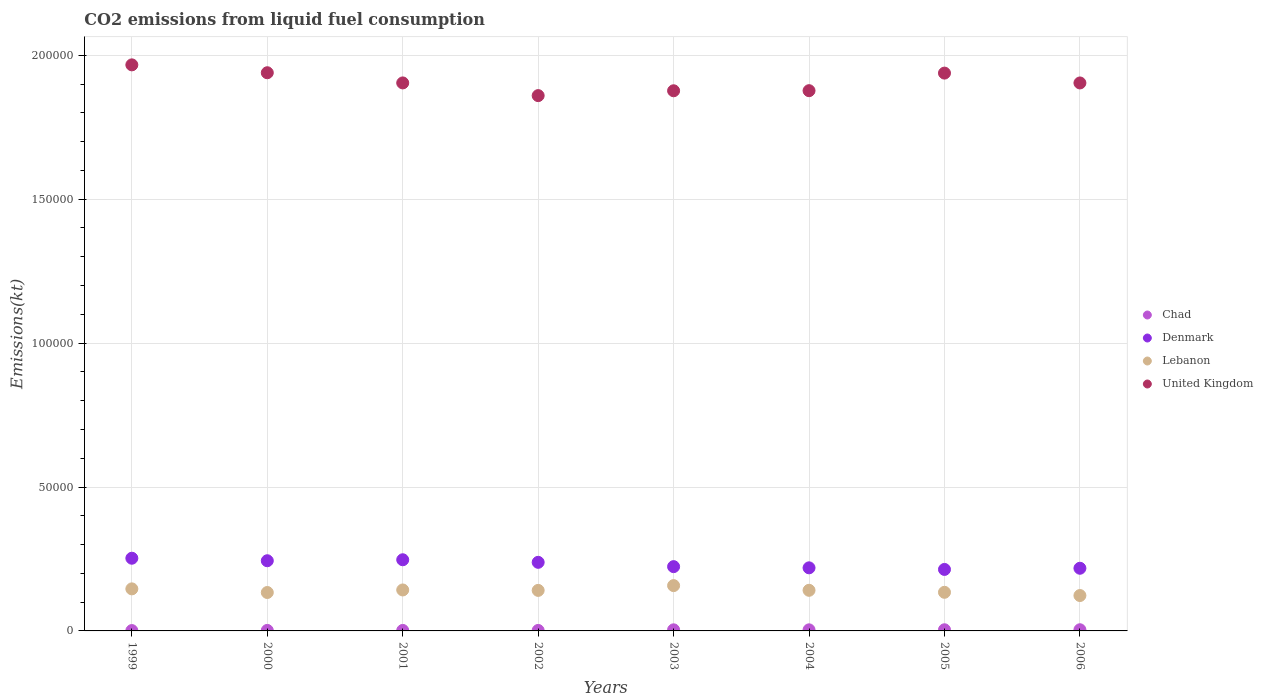How many different coloured dotlines are there?
Provide a succinct answer. 4. What is the amount of CO2 emitted in Chad in 2005?
Offer a terse response. 399.7. Across all years, what is the maximum amount of CO2 emitted in Lebanon?
Offer a very short reply. 1.57e+04. Across all years, what is the minimum amount of CO2 emitted in United Kingdom?
Your answer should be compact. 1.86e+05. In which year was the amount of CO2 emitted in United Kingdom maximum?
Make the answer very short. 1999. In which year was the amount of CO2 emitted in Lebanon minimum?
Ensure brevity in your answer.  2006. What is the total amount of CO2 emitted in Denmark in the graph?
Provide a succinct answer. 1.86e+05. What is the difference between the amount of CO2 emitted in United Kingdom in 2003 and that in 2006?
Make the answer very short. -2717.25. What is the difference between the amount of CO2 emitted in Chad in 2006 and the amount of CO2 emitted in United Kingdom in 2000?
Your answer should be compact. -1.94e+05. What is the average amount of CO2 emitted in Lebanon per year?
Provide a succinct answer. 1.40e+04. In the year 2004, what is the difference between the amount of CO2 emitted in Lebanon and amount of CO2 emitted in Chad?
Provide a short and direct response. 1.37e+04. What is the ratio of the amount of CO2 emitted in Chad in 2000 to that in 2002?
Ensure brevity in your answer.  1.04. Is the difference between the amount of CO2 emitted in Lebanon in 2005 and 2006 greater than the difference between the amount of CO2 emitted in Chad in 2005 and 2006?
Provide a succinct answer. Yes. What is the difference between the highest and the second highest amount of CO2 emitted in Denmark?
Give a very brief answer. 531.72. What is the difference between the highest and the lowest amount of CO2 emitted in Denmark?
Provide a succinct answer. 3890.69. In how many years, is the amount of CO2 emitted in Denmark greater than the average amount of CO2 emitted in Denmark taken over all years?
Provide a succinct answer. 4. Is it the case that in every year, the sum of the amount of CO2 emitted in Denmark and amount of CO2 emitted in Chad  is greater than the amount of CO2 emitted in United Kingdom?
Offer a terse response. No. Does the amount of CO2 emitted in Lebanon monotonically increase over the years?
Your answer should be very brief. No. How many years are there in the graph?
Ensure brevity in your answer.  8. Are the values on the major ticks of Y-axis written in scientific E-notation?
Your response must be concise. No. Does the graph contain grids?
Your answer should be very brief. Yes. How many legend labels are there?
Make the answer very short. 4. How are the legend labels stacked?
Ensure brevity in your answer.  Vertical. What is the title of the graph?
Provide a short and direct response. CO2 emissions from liquid fuel consumption. Does "Denmark" appear as one of the legend labels in the graph?
Your answer should be very brief. Yes. What is the label or title of the Y-axis?
Provide a succinct answer. Emissions(kt). What is the Emissions(kt) of Chad in 1999?
Provide a short and direct response. 121.01. What is the Emissions(kt) of Denmark in 1999?
Your response must be concise. 2.53e+04. What is the Emissions(kt) in Lebanon in 1999?
Offer a very short reply. 1.46e+04. What is the Emissions(kt) in United Kingdom in 1999?
Provide a short and direct response. 1.97e+05. What is the Emissions(kt) of Chad in 2000?
Keep it short and to the point. 176.02. What is the Emissions(kt) of Denmark in 2000?
Your response must be concise. 2.44e+04. What is the Emissions(kt) in Lebanon in 2000?
Offer a terse response. 1.33e+04. What is the Emissions(kt) in United Kingdom in 2000?
Give a very brief answer. 1.94e+05. What is the Emissions(kt) in Chad in 2001?
Offer a terse response. 172.35. What is the Emissions(kt) of Denmark in 2001?
Offer a very short reply. 2.47e+04. What is the Emissions(kt) of Lebanon in 2001?
Keep it short and to the point. 1.42e+04. What is the Emissions(kt) in United Kingdom in 2001?
Ensure brevity in your answer.  1.90e+05. What is the Emissions(kt) in Chad in 2002?
Offer a terse response. 168.68. What is the Emissions(kt) of Denmark in 2002?
Your response must be concise. 2.38e+04. What is the Emissions(kt) of Lebanon in 2002?
Offer a very short reply. 1.41e+04. What is the Emissions(kt) in United Kingdom in 2002?
Offer a terse response. 1.86e+05. What is the Emissions(kt) in Chad in 2003?
Provide a succinct answer. 381.37. What is the Emissions(kt) in Denmark in 2003?
Offer a terse response. 2.23e+04. What is the Emissions(kt) in Lebanon in 2003?
Offer a very short reply. 1.57e+04. What is the Emissions(kt) in United Kingdom in 2003?
Provide a succinct answer. 1.88e+05. What is the Emissions(kt) in Chad in 2004?
Your answer should be very brief. 377.7. What is the Emissions(kt) of Denmark in 2004?
Your response must be concise. 2.19e+04. What is the Emissions(kt) in Lebanon in 2004?
Make the answer very short. 1.41e+04. What is the Emissions(kt) of United Kingdom in 2004?
Your response must be concise. 1.88e+05. What is the Emissions(kt) of Chad in 2005?
Your response must be concise. 399.7. What is the Emissions(kt) in Denmark in 2005?
Make the answer very short. 2.14e+04. What is the Emissions(kt) in Lebanon in 2005?
Provide a short and direct response. 1.34e+04. What is the Emissions(kt) of United Kingdom in 2005?
Provide a short and direct response. 1.94e+05. What is the Emissions(kt) in Chad in 2006?
Make the answer very short. 407.04. What is the Emissions(kt) in Denmark in 2006?
Give a very brief answer. 2.18e+04. What is the Emissions(kt) of Lebanon in 2006?
Give a very brief answer. 1.23e+04. What is the Emissions(kt) in United Kingdom in 2006?
Provide a succinct answer. 1.90e+05. Across all years, what is the maximum Emissions(kt) of Chad?
Offer a terse response. 407.04. Across all years, what is the maximum Emissions(kt) in Denmark?
Keep it short and to the point. 2.53e+04. Across all years, what is the maximum Emissions(kt) in Lebanon?
Keep it short and to the point. 1.57e+04. Across all years, what is the maximum Emissions(kt) of United Kingdom?
Give a very brief answer. 1.97e+05. Across all years, what is the minimum Emissions(kt) in Chad?
Your response must be concise. 121.01. Across all years, what is the minimum Emissions(kt) of Denmark?
Offer a very short reply. 2.14e+04. Across all years, what is the minimum Emissions(kt) in Lebanon?
Your response must be concise. 1.23e+04. Across all years, what is the minimum Emissions(kt) of United Kingdom?
Provide a short and direct response. 1.86e+05. What is the total Emissions(kt) in Chad in the graph?
Provide a succinct answer. 2203.87. What is the total Emissions(kt) of Denmark in the graph?
Provide a short and direct response. 1.86e+05. What is the total Emissions(kt) in Lebanon in the graph?
Your response must be concise. 1.12e+05. What is the total Emissions(kt) in United Kingdom in the graph?
Offer a very short reply. 1.53e+06. What is the difference between the Emissions(kt) of Chad in 1999 and that in 2000?
Ensure brevity in your answer.  -55.01. What is the difference between the Emissions(kt) of Denmark in 1999 and that in 2000?
Ensure brevity in your answer.  872.75. What is the difference between the Emissions(kt) in Lebanon in 1999 and that in 2000?
Provide a succinct answer. 1261.45. What is the difference between the Emissions(kt) in United Kingdom in 1999 and that in 2000?
Your answer should be very brief. 2739.25. What is the difference between the Emissions(kt) in Chad in 1999 and that in 2001?
Give a very brief answer. -51.34. What is the difference between the Emissions(kt) of Denmark in 1999 and that in 2001?
Ensure brevity in your answer.  531.72. What is the difference between the Emissions(kt) in Lebanon in 1999 and that in 2001?
Ensure brevity in your answer.  377.7. What is the difference between the Emissions(kt) of United Kingdom in 1999 and that in 2001?
Provide a succinct answer. 6274.24. What is the difference between the Emissions(kt) of Chad in 1999 and that in 2002?
Your answer should be very brief. -47.67. What is the difference between the Emissions(kt) in Denmark in 1999 and that in 2002?
Provide a succinct answer. 1422.8. What is the difference between the Emissions(kt) in Lebanon in 1999 and that in 2002?
Your answer should be compact. 528.05. What is the difference between the Emissions(kt) in United Kingdom in 1999 and that in 2002?
Offer a terse response. 1.07e+04. What is the difference between the Emissions(kt) in Chad in 1999 and that in 2003?
Your answer should be compact. -260.36. What is the difference between the Emissions(kt) of Denmark in 1999 and that in 2003?
Keep it short and to the point. 2922.6. What is the difference between the Emissions(kt) of Lebanon in 1999 and that in 2003?
Your answer should be compact. -1133.1. What is the difference between the Emissions(kt) in United Kingdom in 1999 and that in 2003?
Make the answer very short. 9002.49. What is the difference between the Emissions(kt) of Chad in 1999 and that in 2004?
Offer a terse response. -256.69. What is the difference between the Emissions(kt) in Denmark in 1999 and that in 2004?
Offer a very short reply. 3336.97. What is the difference between the Emissions(kt) in Lebanon in 1999 and that in 2004?
Provide a succinct answer. 498.71. What is the difference between the Emissions(kt) of United Kingdom in 1999 and that in 2004?
Give a very brief answer. 8969.48. What is the difference between the Emissions(kt) in Chad in 1999 and that in 2005?
Provide a short and direct response. -278.69. What is the difference between the Emissions(kt) in Denmark in 1999 and that in 2005?
Keep it short and to the point. 3890.69. What is the difference between the Emissions(kt) in Lebanon in 1999 and that in 2005?
Your response must be concise. 1191.78. What is the difference between the Emissions(kt) in United Kingdom in 1999 and that in 2005?
Offer a terse response. 2863.93. What is the difference between the Emissions(kt) of Chad in 1999 and that in 2006?
Your answer should be compact. -286.03. What is the difference between the Emissions(kt) in Denmark in 1999 and that in 2006?
Your response must be concise. 3483.65. What is the difference between the Emissions(kt) in Lebanon in 1999 and that in 2006?
Your answer should be very brief. 2313.88. What is the difference between the Emissions(kt) of United Kingdom in 1999 and that in 2006?
Offer a terse response. 6285.24. What is the difference between the Emissions(kt) of Chad in 2000 and that in 2001?
Give a very brief answer. 3.67. What is the difference between the Emissions(kt) of Denmark in 2000 and that in 2001?
Offer a very short reply. -341.03. What is the difference between the Emissions(kt) of Lebanon in 2000 and that in 2001?
Make the answer very short. -883.75. What is the difference between the Emissions(kt) of United Kingdom in 2000 and that in 2001?
Offer a terse response. 3534.99. What is the difference between the Emissions(kt) in Chad in 2000 and that in 2002?
Make the answer very short. 7.33. What is the difference between the Emissions(kt) of Denmark in 2000 and that in 2002?
Your response must be concise. 550.05. What is the difference between the Emissions(kt) of Lebanon in 2000 and that in 2002?
Offer a terse response. -733.4. What is the difference between the Emissions(kt) in United Kingdom in 2000 and that in 2002?
Offer a very short reply. 7946.39. What is the difference between the Emissions(kt) of Chad in 2000 and that in 2003?
Provide a succinct answer. -205.35. What is the difference between the Emissions(kt) in Denmark in 2000 and that in 2003?
Offer a very short reply. 2049.85. What is the difference between the Emissions(kt) in Lebanon in 2000 and that in 2003?
Ensure brevity in your answer.  -2394.55. What is the difference between the Emissions(kt) of United Kingdom in 2000 and that in 2003?
Provide a succinct answer. 6263.24. What is the difference between the Emissions(kt) in Chad in 2000 and that in 2004?
Provide a short and direct response. -201.69. What is the difference between the Emissions(kt) in Denmark in 2000 and that in 2004?
Offer a terse response. 2464.22. What is the difference between the Emissions(kt) in Lebanon in 2000 and that in 2004?
Your answer should be very brief. -762.74. What is the difference between the Emissions(kt) of United Kingdom in 2000 and that in 2004?
Provide a succinct answer. 6230.23. What is the difference between the Emissions(kt) in Chad in 2000 and that in 2005?
Your response must be concise. -223.69. What is the difference between the Emissions(kt) in Denmark in 2000 and that in 2005?
Your answer should be very brief. 3017.94. What is the difference between the Emissions(kt) of Lebanon in 2000 and that in 2005?
Give a very brief answer. -69.67. What is the difference between the Emissions(kt) in United Kingdom in 2000 and that in 2005?
Give a very brief answer. 124.68. What is the difference between the Emissions(kt) of Chad in 2000 and that in 2006?
Keep it short and to the point. -231.02. What is the difference between the Emissions(kt) of Denmark in 2000 and that in 2006?
Offer a very short reply. 2610.9. What is the difference between the Emissions(kt) of Lebanon in 2000 and that in 2006?
Give a very brief answer. 1052.43. What is the difference between the Emissions(kt) in United Kingdom in 2000 and that in 2006?
Your answer should be very brief. 3545.99. What is the difference between the Emissions(kt) of Chad in 2001 and that in 2002?
Offer a terse response. 3.67. What is the difference between the Emissions(kt) of Denmark in 2001 and that in 2002?
Keep it short and to the point. 891.08. What is the difference between the Emissions(kt) of Lebanon in 2001 and that in 2002?
Offer a very short reply. 150.35. What is the difference between the Emissions(kt) in United Kingdom in 2001 and that in 2002?
Provide a short and direct response. 4411.4. What is the difference between the Emissions(kt) of Chad in 2001 and that in 2003?
Your answer should be compact. -209.02. What is the difference between the Emissions(kt) of Denmark in 2001 and that in 2003?
Keep it short and to the point. 2390.88. What is the difference between the Emissions(kt) in Lebanon in 2001 and that in 2003?
Offer a very short reply. -1510.8. What is the difference between the Emissions(kt) of United Kingdom in 2001 and that in 2003?
Ensure brevity in your answer.  2728.25. What is the difference between the Emissions(kt) in Chad in 2001 and that in 2004?
Your answer should be compact. -205.35. What is the difference between the Emissions(kt) in Denmark in 2001 and that in 2004?
Keep it short and to the point. 2805.26. What is the difference between the Emissions(kt) in Lebanon in 2001 and that in 2004?
Keep it short and to the point. 121.01. What is the difference between the Emissions(kt) of United Kingdom in 2001 and that in 2004?
Your answer should be very brief. 2695.24. What is the difference between the Emissions(kt) of Chad in 2001 and that in 2005?
Provide a succinct answer. -227.35. What is the difference between the Emissions(kt) in Denmark in 2001 and that in 2005?
Provide a short and direct response. 3358.97. What is the difference between the Emissions(kt) in Lebanon in 2001 and that in 2005?
Give a very brief answer. 814.07. What is the difference between the Emissions(kt) in United Kingdom in 2001 and that in 2005?
Offer a very short reply. -3410.31. What is the difference between the Emissions(kt) of Chad in 2001 and that in 2006?
Your response must be concise. -234.69. What is the difference between the Emissions(kt) of Denmark in 2001 and that in 2006?
Give a very brief answer. 2951.93. What is the difference between the Emissions(kt) in Lebanon in 2001 and that in 2006?
Your answer should be compact. 1936.18. What is the difference between the Emissions(kt) in United Kingdom in 2001 and that in 2006?
Your response must be concise. 11. What is the difference between the Emissions(kt) of Chad in 2002 and that in 2003?
Provide a succinct answer. -212.69. What is the difference between the Emissions(kt) in Denmark in 2002 and that in 2003?
Make the answer very short. 1499.8. What is the difference between the Emissions(kt) of Lebanon in 2002 and that in 2003?
Provide a short and direct response. -1661.15. What is the difference between the Emissions(kt) of United Kingdom in 2002 and that in 2003?
Your answer should be compact. -1683.15. What is the difference between the Emissions(kt) of Chad in 2002 and that in 2004?
Keep it short and to the point. -209.02. What is the difference between the Emissions(kt) of Denmark in 2002 and that in 2004?
Offer a terse response. 1914.17. What is the difference between the Emissions(kt) of Lebanon in 2002 and that in 2004?
Give a very brief answer. -29.34. What is the difference between the Emissions(kt) in United Kingdom in 2002 and that in 2004?
Your response must be concise. -1716.16. What is the difference between the Emissions(kt) of Chad in 2002 and that in 2005?
Your answer should be compact. -231.02. What is the difference between the Emissions(kt) in Denmark in 2002 and that in 2005?
Give a very brief answer. 2467.89. What is the difference between the Emissions(kt) of Lebanon in 2002 and that in 2005?
Provide a succinct answer. 663.73. What is the difference between the Emissions(kt) in United Kingdom in 2002 and that in 2005?
Offer a terse response. -7821.71. What is the difference between the Emissions(kt) of Chad in 2002 and that in 2006?
Ensure brevity in your answer.  -238.35. What is the difference between the Emissions(kt) of Denmark in 2002 and that in 2006?
Provide a succinct answer. 2060.85. What is the difference between the Emissions(kt) of Lebanon in 2002 and that in 2006?
Offer a very short reply. 1785.83. What is the difference between the Emissions(kt) in United Kingdom in 2002 and that in 2006?
Offer a terse response. -4400.4. What is the difference between the Emissions(kt) in Chad in 2003 and that in 2004?
Give a very brief answer. 3.67. What is the difference between the Emissions(kt) in Denmark in 2003 and that in 2004?
Offer a very short reply. 414.37. What is the difference between the Emissions(kt) of Lebanon in 2003 and that in 2004?
Offer a very short reply. 1631.82. What is the difference between the Emissions(kt) in United Kingdom in 2003 and that in 2004?
Offer a terse response. -33. What is the difference between the Emissions(kt) in Chad in 2003 and that in 2005?
Your response must be concise. -18.34. What is the difference between the Emissions(kt) of Denmark in 2003 and that in 2005?
Provide a succinct answer. 968.09. What is the difference between the Emissions(kt) of Lebanon in 2003 and that in 2005?
Give a very brief answer. 2324.88. What is the difference between the Emissions(kt) in United Kingdom in 2003 and that in 2005?
Your answer should be very brief. -6138.56. What is the difference between the Emissions(kt) in Chad in 2003 and that in 2006?
Provide a short and direct response. -25.67. What is the difference between the Emissions(kt) in Denmark in 2003 and that in 2006?
Provide a short and direct response. 561.05. What is the difference between the Emissions(kt) of Lebanon in 2003 and that in 2006?
Give a very brief answer. 3446.98. What is the difference between the Emissions(kt) of United Kingdom in 2003 and that in 2006?
Provide a short and direct response. -2717.25. What is the difference between the Emissions(kt) in Chad in 2004 and that in 2005?
Make the answer very short. -22. What is the difference between the Emissions(kt) of Denmark in 2004 and that in 2005?
Provide a short and direct response. 553.72. What is the difference between the Emissions(kt) in Lebanon in 2004 and that in 2005?
Keep it short and to the point. 693.06. What is the difference between the Emissions(kt) in United Kingdom in 2004 and that in 2005?
Make the answer very short. -6105.56. What is the difference between the Emissions(kt) of Chad in 2004 and that in 2006?
Your answer should be very brief. -29.34. What is the difference between the Emissions(kt) of Denmark in 2004 and that in 2006?
Your response must be concise. 146.68. What is the difference between the Emissions(kt) in Lebanon in 2004 and that in 2006?
Offer a terse response. 1815.16. What is the difference between the Emissions(kt) of United Kingdom in 2004 and that in 2006?
Offer a very short reply. -2684.24. What is the difference between the Emissions(kt) of Chad in 2005 and that in 2006?
Keep it short and to the point. -7.33. What is the difference between the Emissions(kt) of Denmark in 2005 and that in 2006?
Give a very brief answer. -407.04. What is the difference between the Emissions(kt) in Lebanon in 2005 and that in 2006?
Your answer should be compact. 1122.1. What is the difference between the Emissions(kt) of United Kingdom in 2005 and that in 2006?
Your answer should be compact. 3421.31. What is the difference between the Emissions(kt) of Chad in 1999 and the Emissions(kt) of Denmark in 2000?
Ensure brevity in your answer.  -2.43e+04. What is the difference between the Emissions(kt) in Chad in 1999 and the Emissions(kt) in Lebanon in 2000?
Ensure brevity in your answer.  -1.32e+04. What is the difference between the Emissions(kt) in Chad in 1999 and the Emissions(kt) in United Kingdom in 2000?
Your answer should be compact. -1.94e+05. What is the difference between the Emissions(kt) of Denmark in 1999 and the Emissions(kt) of Lebanon in 2000?
Offer a terse response. 1.19e+04. What is the difference between the Emissions(kt) in Denmark in 1999 and the Emissions(kt) in United Kingdom in 2000?
Offer a terse response. -1.69e+05. What is the difference between the Emissions(kt) of Lebanon in 1999 and the Emissions(kt) of United Kingdom in 2000?
Ensure brevity in your answer.  -1.79e+05. What is the difference between the Emissions(kt) in Chad in 1999 and the Emissions(kt) in Denmark in 2001?
Offer a very short reply. -2.46e+04. What is the difference between the Emissions(kt) in Chad in 1999 and the Emissions(kt) in Lebanon in 2001?
Provide a short and direct response. -1.41e+04. What is the difference between the Emissions(kt) in Chad in 1999 and the Emissions(kt) in United Kingdom in 2001?
Your response must be concise. -1.90e+05. What is the difference between the Emissions(kt) of Denmark in 1999 and the Emissions(kt) of Lebanon in 2001?
Your response must be concise. 1.10e+04. What is the difference between the Emissions(kt) in Denmark in 1999 and the Emissions(kt) in United Kingdom in 2001?
Offer a terse response. -1.65e+05. What is the difference between the Emissions(kt) in Lebanon in 1999 and the Emissions(kt) in United Kingdom in 2001?
Offer a terse response. -1.76e+05. What is the difference between the Emissions(kt) of Chad in 1999 and the Emissions(kt) of Denmark in 2002?
Your answer should be very brief. -2.37e+04. What is the difference between the Emissions(kt) of Chad in 1999 and the Emissions(kt) of Lebanon in 2002?
Your response must be concise. -1.40e+04. What is the difference between the Emissions(kt) in Chad in 1999 and the Emissions(kt) in United Kingdom in 2002?
Ensure brevity in your answer.  -1.86e+05. What is the difference between the Emissions(kt) in Denmark in 1999 and the Emissions(kt) in Lebanon in 2002?
Ensure brevity in your answer.  1.12e+04. What is the difference between the Emissions(kt) in Denmark in 1999 and the Emissions(kt) in United Kingdom in 2002?
Keep it short and to the point. -1.61e+05. What is the difference between the Emissions(kt) of Lebanon in 1999 and the Emissions(kt) of United Kingdom in 2002?
Offer a terse response. -1.71e+05. What is the difference between the Emissions(kt) in Chad in 1999 and the Emissions(kt) in Denmark in 2003?
Make the answer very short. -2.22e+04. What is the difference between the Emissions(kt) of Chad in 1999 and the Emissions(kt) of Lebanon in 2003?
Provide a succinct answer. -1.56e+04. What is the difference between the Emissions(kt) of Chad in 1999 and the Emissions(kt) of United Kingdom in 2003?
Your answer should be compact. -1.88e+05. What is the difference between the Emissions(kt) of Denmark in 1999 and the Emissions(kt) of Lebanon in 2003?
Ensure brevity in your answer.  9512.2. What is the difference between the Emissions(kt) in Denmark in 1999 and the Emissions(kt) in United Kingdom in 2003?
Keep it short and to the point. -1.62e+05. What is the difference between the Emissions(kt) of Lebanon in 1999 and the Emissions(kt) of United Kingdom in 2003?
Your answer should be compact. -1.73e+05. What is the difference between the Emissions(kt) in Chad in 1999 and the Emissions(kt) in Denmark in 2004?
Make the answer very short. -2.18e+04. What is the difference between the Emissions(kt) of Chad in 1999 and the Emissions(kt) of Lebanon in 2004?
Provide a succinct answer. -1.40e+04. What is the difference between the Emissions(kt) in Chad in 1999 and the Emissions(kt) in United Kingdom in 2004?
Offer a terse response. -1.88e+05. What is the difference between the Emissions(kt) in Denmark in 1999 and the Emissions(kt) in Lebanon in 2004?
Your answer should be very brief. 1.11e+04. What is the difference between the Emissions(kt) of Denmark in 1999 and the Emissions(kt) of United Kingdom in 2004?
Your answer should be very brief. -1.62e+05. What is the difference between the Emissions(kt) of Lebanon in 1999 and the Emissions(kt) of United Kingdom in 2004?
Provide a short and direct response. -1.73e+05. What is the difference between the Emissions(kt) in Chad in 1999 and the Emissions(kt) in Denmark in 2005?
Ensure brevity in your answer.  -2.12e+04. What is the difference between the Emissions(kt) of Chad in 1999 and the Emissions(kt) of Lebanon in 2005?
Your answer should be compact. -1.33e+04. What is the difference between the Emissions(kt) of Chad in 1999 and the Emissions(kt) of United Kingdom in 2005?
Provide a succinct answer. -1.94e+05. What is the difference between the Emissions(kt) in Denmark in 1999 and the Emissions(kt) in Lebanon in 2005?
Your answer should be very brief. 1.18e+04. What is the difference between the Emissions(kt) in Denmark in 1999 and the Emissions(kt) in United Kingdom in 2005?
Your answer should be compact. -1.69e+05. What is the difference between the Emissions(kt) in Lebanon in 1999 and the Emissions(kt) in United Kingdom in 2005?
Ensure brevity in your answer.  -1.79e+05. What is the difference between the Emissions(kt) of Chad in 1999 and the Emissions(kt) of Denmark in 2006?
Make the answer very short. -2.16e+04. What is the difference between the Emissions(kt) of Chad in 1999 and the Emissions(kt) of Lebanon in 2006?
Ensure brevity in your answer.  -1.22e+04. What is the difference between the Emissions(kt) of Chad in 1999 and the Emissions(kt) of United Kingdom in 2006?
Ensure brevity in your answer.  -1.90e+05. What is the difference between the Emissions(kt) in Denmark in 1999 and the Emissions(kt) in Lebanon in 2006?
Your response must be concise. 1.30e+04. What is the difference between the Emissions(kt) in Denmark in 1999 and the Emissions(kt) in United Kingdom in 2006?
Give a very brief answer. -1.65e+05. What is the difference between the Emissions(kt) of Lebanon in 1999 and the Emissions(kt) of United Kingdom in 2006?
Ensure brevity in your answer.  -1.76e+05. What is the difference between the Emissions(kt) of Chad in 2000 and the Emissions(kt) of Denmark in 2001?
Offer a very short reply. -2.45e+04. What is the difference between the Emissions(kt) of Chad in 2000 and the Emissions(kt) of Lebanon in 2001?
Offer a terse response. -1.41e+04. What is the difference between the Emissions(kt) of Chad in 2000 and the Emissions(kt) of United Kingdom in 2001?
Offer a terse response. -1.90e+05. What is the difference between the Emissions(kt) in Denmark in 2000 and the Emissions(kt) in Lebanon in 2001?
Your response must be concise. 1.02e+04. What is the difference between the Emissions(kt) of Denmark in 2000 and the Emissions(kt) of United Kingdom in 2001?
Offer a terse response. -1.66e+05. What is the difference between the Emissions(kt) in Lebanon in 2000 and the Emissions(kt) in United Kingdom in 2001?
Offer a very short reply. -1.77e+05. What is the difference between the Emissions(kt) of Chad in 2000 and the Emissions(kt) of Denmark in 2002?
Your answer should be very brief. -2.37e+04. What is the difference between the Emissions(kt) in Chad in 2000 and the Emissions(kt) in Lebanon in 2002?
Offer a very short reply. -1.39e+04. What is the difference between the Emissions(kt) in Chad in 2000 and the Emissions(kt) in United Kingdom in 2002?
Provide a succinct answer. -1.86e+05. What is the difference between the Emissions(kt) of Denmark in 2000 and the Emissions(kt) of Lebanon in 2002?
Make the answer very short. 1.03e+04. What is the difference between the Emissions(kt) of Denmark in 2000 and the Emissions(kt) of United Kingdom in 2002?
Provide a short and direct response. -1.62e+05. What is the difference between the Emissions(kt) in Lebanon in 2000 and the Emissions(kt) in United Kingdom in 2002?
Provide a short and direct response. -1.73e+05. What is the difference between the Emissions(kt) in Chad in 2000 and the Emissions(kt) in Denmark in 2003?
Keep it short and to the point. -2.22e+04. What is the difference between the Emissions(kt) in Chad in 2000 and the Emissions(kt) in Lebanon in 2003?
Your response must be concise. -1.56e+04. What is the difference between the Emissions(kt) in Chad in 2000 and the Emissions(kt) in United Kingdom in 2003?
Your answer should be compact. -1.87e+05. What is the difference between the Emissions(kt) of Denmark in 2000 and the Emissions(kt) of Lebanon in 2003?
Make the answer very short. 8639.45. What is the difference between the Emissions(kt) in Denmark in 2000 and the Emissions(kt) in United Kingdom in 2003?
Make the answer very short. -1.63e+05. What is the difference between the Emissions(kt) in Lebanon in 2000 and the Emissions(kt) in United Kingdom in 2003?
Offer a very short reply. -1.74e+05. What is the difference between the Emissions(kt) in Chad in 2000 and the Emissions(kt) in Denmark in 2004?
Give a very brief answer. -2.17e+04. What is the difference between the Emissions(kt) of Chad in 2000 and the Emissions(kt) of Lebanon in 2004?
Give a very brief answer. -1.39e+04. What is the difference between the Emissions(kt) of Chad in 2000 and the Emissions(kt) of United Kingdom in 2004?
Give a very brief answer. -1.88e+05. What is the difference between the Emissions(kt) in Denmark in 2000 and the Emissions(kt) in Lebanon in 2004?
Make the answer very short. 1.03e+04. What is the difference between the Emissions(kt) of Denmark in 2000 and the Emissions(kt) of United Kingdom in 2004?
Your answer should be very brief. -1.63e+05. What is the difference between the Emissions(kt) of Lebanon in 2000 and the Emissions(kt) of United Kingdom in 2004?
Give a very brief answer. -1.74e+05. What is the difference between the Emissions(kt) in Chad in 2000 and the Emissions(kt) in Denmark in 2005?
Offer a very short reply. -2.12e+04. What is the difference between the Emissions(kt) of Chad in 2000 and the Emissions(kt) of Lebanon in 2005?
Keep it short and to the point. -1.32e+04. What is the difference between the Emissions(kt) in Chad in 2000 and the Emissions(kt) in United Kingdom in 2005?
Your answer should be very brief. -1.94e+05. What is the difference between the Emissions(kt) in Denmark in 2000 and the Emissions(kt) in Lebanon in 2005?
Offer a terse response. 1.10e+04. What is the difference between the Emissions(kt) of Denmark in 2000 and the Emissions(kt) of United Kingdom in 2005?
Keep it short and to the point. -1.69e+05. What is the difference between the Emissions(kt) in Lebanon in 2000 and the Emissions(kt) in United Kingdom in 2005?
Offer a terse response. -1.80e+05. What is the difference between the Emissions(kt) in Chad in 2000 and the Emissions(kt) in Denmark in 2006?
Keep it short and to the point. -2.16e+04. What is the difference between the Emissions(kt) in Chad in 2000 and the Emissions(kt) in Lebanon in 2006?
Your answer should be compact. -1.21e+04. What is the difference between the Emissions(kt) of Chad in 2000 and the Emissions(kt) of United Kingdom in 2006?
Make the answer very short. -1.90e+05. What is the difference between the Emissions(kt) of Denmark in 2000 and the Emissions(kt) of Lebanon in 2006?
Offer a very short reply. 1.21e+04. What is the difference between the Emissions(kt) in Denmark in 2000 and the Emissions(kt) in United Kingdom in 2006?
Your answer should be compact. -1.66e+05. What is the difference between the Emissions(kt) in Lebanon in 2000 and the Emissions(kt) in United Kingdom in 2006?
Give a very brief answer. -1.77e+05. What is the difference between the Emissions(kt) in Chad in 2001 and the Emissions(kt) in Denmark in 2002?
Offer a terse response. -2.37e+04. What is the difference between the Emissions(kt) in Chad in 2001 and the Emissions(kt) in Lebanon in 2002?
Give a very brief answer. -1.39e+04. What is the difference between the Emissions(kt) of Chad in 2001 and the Emissions(kt) of United Kingdom in 2002?
Offer a terse response. -1.86e+05. What is the difference between the Emissions(kt) in Denmark in 2001 and the Emissions(kt) in Lebanon in 2002?
Give a very brief answer. 1.06e+04. What is the difference between the Emissions(kt) of Denmark in 2001 and the Emissions(kt) of United Kingdom in 2002?
Your answer should be compact. -1.61e+05. What is the difference between the Emissions(kt) in Lebanon in 2001 and the Emissions(kt) in United Kingdom in 2002?
Provide a short and direct response. -1.72e+05. What is the difference between the Emissions(kt) of Chad in 2001 and the Emissions(kt) of Denmark in 2003?
Offer a terse response. -2.22e+04. What is the difference between the Emissions(kt) of Chad in 2001 and the Emissions(kt) of Lebanon in 2003?
Make the answer very short. -1.56e+04. What is the difference between the Emissions(kt) of Chad in 2001 and the Emissions(kt) of United Kingdom in 2003?
Your answer should be compact. -1.87e+05. What is the difference between the Emissions(kt) in Denmark in 2001 and the Emissions(kt) in Lebanon in 2003?
Offer a very short reply. 8980.48. What is the difference between the Emissions(kt) of Denmark in 2001 and the Emissions(kt) of United Kingdom in 2003?
Provide a succinct answer. -1.63e+05. What is the difference between the Emissions(kt) of Lebanon in 2001 and the Emissions(kt) of United Kingdom in 2003?
Offer a very short reply. -1.73e+05. What is the difference between the Emissions(kt) in Chad in 2001 and the Emissions(kt) in Denmark in 2004?
Give a very brief answer. -2.17e+04. What is the difference between the Emissions(kt) of Chad in 2001 and the Emissions(kt) of Lebanon in 2004?
Keep it short and to the point. -1.39e+04. What is the difference between the Emissions(kt) of Chad in 2001 and the Emissions(kt) of United Kingdom in 2004?
Your answer should be very brief. -1.88e+05. What is the difference between the Emissions(kt) in Denmark in 2001 and the Emissions(kt) in Lebanon in 2004?
Your answer should be compact. 1.06e+04. What is the difference between the Emissions(kt) in Denmark in 2001 and the Emissions(kt) in United Kingdom in 2004?
Provide a succinct answer. -1.63e+05. What is the difference between the Emissions(kt) of Lebanon in 2001 and the Emissions(kt) of United Kingdom in 2004?
Provide a succinct answer. -1.73e+05. What is the difference between the Emissions(kt) in Chad in 2001 and the Emissions(kt) in Denmark in 2005?
Ensure brevity in your answer.  -2.12e+04. What is the difference between the Emissions(kt) of Chad in 2001 and the Emissions(kt) of Lebanon in 2005?
Give a very brief answer. -1.32e+04. What is the difference between the Emissions(kt) of Chad in 2001 and the Emissions(kt) of United Kingdom in 2005?
Provide a short and direct response. -1.94e+05. What is the difference between the Emissions(kt) in Denmark in 2001 and the Emissions(kt) in Lebanon in 2005?
Offer a very short reply. 1.13e+04. What is the difference between the Emissions(kt) of Denmark in 2001 and the Emissions(kt) of United Kingdom in 2005?
Give a very brief answer. -1.69e+05. What is the difference between the Emissions(kt) of Lebanon in 2001 and the Emissions(kt) of United Kingdom in 2005?
Provide a short and direct response. -1.80e+05. What is the difference between the Emissions(kt) of Chad in 2001 and the Emissions(kt) of Denmark in 2006?
Offer a terse response. -2.16e+04. What is the difference between the Emissions(kt) of Chad in 2001 and the Emissions(kt) of Lebanon in 2006?
Keep it short and to the point. -1.21e+04. What is the difference between the Emissions(kt) in Chad in 2001 and the Emissions(kt) in United Kingdom in 2006?
Keep it short and to the point. -1.90e+05. What is the difference between the Emissions(kt) of Denmark in 2001 and the Emissions(kt) of Lebanon in 2006?
Your answer should be very brief. 1.24e+04. What is the difference between the Emissions(kt) of Denmark in 2001 and the Emissions(kt) of United Kingdom in 2006?
Make the answer very short. -1.66e+05. What is the difference between the Emissions(kt) in Lebanon in 2001 and the Emissions(kt) in United Kingdom in 2006?
Provide a succinct answer. -1.76e+05. What is the difference between the Emissions(kt) in Chad in 2002 and the Emissions(kt) in Denmark in 2003?
Ensure brevity in your answer.  -2.22e+04. What is the difference between the Emissions(kt) in Chad in 2002 and the Emissions(kt) in Lebanon in 2003?
Provide a short and direct response. -1.56e+04. What is the difference between the Emissions(kt) of Chad in 2002 and the Emissions(kt) of United Kingdom in 2003?
Make the answer very short. -1.87e+05. What is the difference between the Emissions(kt) of Denmark in 2002 and the Emissions(kt) of Lebanon in 2003?
Keep it short and to the point. 8089.4. What is the difference between the Emissions(kt) of Denmark in 2002 and the Emissions(kt) of United Kingdom in 2003?
Make the answer very short. -1.64e+05. What is the difference between the Emissions(kt) in Lebanon in 2002 and the Emissions(kt) in United Kingdom in 2003?
Your response must be concise. -1.74e+05. What is the difference between the Emissions(kt) of Chad in 2002 and the Emissions(kt) of Denmark in 2004?
Provide a short and direct response. -2.17e+04. What is the difference between the Emissions(kt) in Chad in 2002 and the Emissions(kt) in Lebanon in 2004?
Provide a succinct answer. -1.39e+04. What is the difference between the Emissions(kt) of Chad in 2002 and the Emissions(kt) of United Kingdom in 2004?
Ensure brevity in your answer.  -1.88e+05. What is the difference between the Emissions(kt) of Denmark in 2002 and the Emissions(kt) of Lebanon in 2004?
Keep it short and to the point. 9721.22. What is the difference between the Emissions(kt) in Denmark in 2002 and the Emissions(kt) in United Kingdom in 2004?
Provide a succinct answer. -1.64e+05. What is the difference between the Emissions(kt) of Lebanon in 2002 and the Emissions(kt) of United Kingdom in 2004?
Offer a terse response. -1.74e+05. What is the difference between the Emissions(kt) in Chad in 2002 and the Emissions(kt) in Denmark in 2005?
Provide a short and direct response. -2.12e+04. What is the difference between the Emissions(kt) in Chad in 2002 and the Emissions(kt) in Lebanon in 2005?
Give a very brief answer. -1.32e+04. What is the difference between the Emissions(kt) of Chad in 2002 and the Emissions(kt) of United Kingdom in 2005?
Offer a very short reply. -1.94e+05. What is the difference between the Emissions(kt) in Denmark in 2002 and the Emissions(kt) in Lebanon in 2005?
Keep it short and to the point. 1.04e+04. What is the difference between the Emissions(kt) in Denmark in 2002 and the Emissions(kt) in United Kingdom in 2005?
Your answer should be compact. -1.70e+05. What is the difference between the Emissions(kt) of Lebanon in 2002 and the Emissions(kt) of United Kingdom in 2005?
Your response must be concise. -1.80e+05. What is the difference between the Emissions(kt) of Chad in 2002 and the Emissions(kt) of Denmark in 2006?
Make the answer very short. -2.16e+04. What is the difference between the Emissions(kt) in Chad in 2002 and the Emissions(kt) in Lebanon in 2006?
Ensure brevity in your answer.  -1.21e+04. What is the difference between the Emissions(kt) in Chad in 2002 and the Emissions(kt) in United Kingdom in 2006?
Your answer should be very brief. -1.90e+05. What is the difference between the Emissions(kt) of Denmark in 2002 and the Emissions(kt) of Lebanon in 2006?
Give a very brief answer. 1.15e+04. What is the difference between the Emissions(kt) of Denmark in 2002 and the Emissions(kt) of United Kingdom in 2006?
Ensure brevity in your answer.  -1.67e+05. What is the difference between the Emissions(kt) of Lebanon in 2002 and the Emissions(kt) of United Kingdom in 2006?
Your response must be concise. -1.76e+05. What is the difference between the Emissions(kt) of Chad in 2003 and the Emissions(kt) of Denmark in 2004?
Give a very brief answer. -2.15e+04. What is the difference between the Emissions(kt) of Chad in 2003 and the Emissions(kt) of Lebanon in 2004?
Ensure brevity in your answer.  -1.37e+04. What is the difference between the Emissions(kt) of Chad in 2003 and the Emissions(kt) of United Kingdom in 2004?
Make the answer very short. -1.87e+05. What is the difference between the Emissions(kt) in Denmark in 2003 and the Emissions(kt) in Lebanon in 2004?
Your answer should be compact. 8221.41. What is the difference between the Emissions(kt) of Denmark in 2003 and the Emissions(kt) of United Kingdom in 2004?
Make the answer very short. -1.65e+05. What is the difference between the Emissions(kt) in Lebanon in 2003 and the Emissions(kt) in United Kingdom in 2004?
Your answer should be very brief. -1.72e+05. What is the difference between the Emissions(kt) of Chad in 2003 and the Emissions(kt) of Denmark in 2005?
Keep it short and to the point. -2.10e+04. What is the difference between the Emissions(kt) of Chad in 2003 and the Emissions(kt) of Lebanon in 2005?
Your response must be concise. -1.30e+04. What is the difference between the Emissions(kt) of Chad in 2003 and the Emissions(kt) of United Kingdom in 2005?
Give a very brief answer. -1.93e+05. What is the difference between the Emissions(kt) of Denmark in 2003 and the Emissions(kt) of Lebanon in 2005?
Provide a short and direct response. 8914.48. What is the difference between the Emissions(kt) in Denmark in 2003 and the Emissions(kt) in United Kingdom in 2005?
Give a very brief answer. -1.71e+05. What is the difference between the Emissions(kt) in Lebanon in 2003 and the Emissions(kt) in United Kingdom in 2005?
Give a very brief answer. -1.78e+05. What is the difference between the Emissions(kt) of Chad in 2003 and the Emissions(kt) of Denmark in 2006?
Offer a very short reply. -2.14e+04. What is the difference between the Emissions(kt) of Chad in 2003 and the Emissions(kt) of Lebanon in 2006?
Offer a terse response. -1.19e+04. What is the difference between the Emissions(kt) in Chad in 2003 and the Emissions(kt) in United Kingdom in 2006?
Make the answer very short. -1.90e+05. What is the difference between the Emissions(kt) in Denmark in 2003 and the Emissions(kt) in Lebanon in 2006?
Provide a short and direct response. 1.00e+04. What is the difference between the Emissions(kt) in Denmark in 2003 and the Emissions(kt) in United Kingdom in 2006?
Make the answer very short. -1.68e+05. What is the difference between the Emissions(kt) of Lebanon in 2003 and the Emissions(kt) of United Kingdom in 2006?
Offer a very short reply. -1.75e+05. What is the difference between the Emissions(kt) in Chad in 2004 and the Emissions(kt) in Denmark in 2005?
Ensure brevity in your answer.  -2.10e+04. What is the difference between the Emissions(kt) of Chad in 2004 and the Emissions(kt) of Lebanon in 2005?
Your response must be concise. -1.30e+04. What is the difference between the Emissions(kt) of Chad in 2004 and the Emissions(kt) of United Kingdom in 2005?
Make the answer very short. -1.93e+05. What is the difference between the Emissions(kt) of Denmark in 2004 and the Emissions(kt) of Lebanon in 2005?
Provide a succinct answer. 8500.11. What is the difference between the Emissions(kt) in Denmark in 2004 and the Emissions(kt) in United Kingdom in 2005?
Offer a very short reply. -1.72e+05. What is the difference between the Emissions(kt) of Lebanon in 2004 and the Emissions(kt) of United Kingdom in 2005?
Provide a succinct answer. -1.80e+05. What is the difference between the Emissions(kt) of Chad in 2004 and the Emissions(kt) of Denmark in 2006?
Your response must be concise. -2.14e+04. What is the difference between the Emissions(kt) of Chad in 2004 and the Emissions(kt) of Lebanon in 2006?
Offer a very short reply. -1.19e+04. What is the difference between the Emissions(kt) in Chad in 2004 and the Emissions(kt) in United Kingdom in 2006?
Make the answer very short. -1.90e+05. What is the difference between the Emissions(kt) in Denmark in 2004 and the Emissions(kt) in Lebanon in 2006?
Offer a very short reply. 9622.21. What is the difference between the Emissions(kt) in Denmark in 2004 and the Emissions(kt) in United Kingdom in 2006?
Offer a very short reply. -1.68e+05. What is the difference between the Emissions(kt) of Lebanon in 2004 and the Emissions(kt) of United Kingdom in 2006?
Ensure brevity in your answer.  -1.76e+05. What is the difference between the Emissions(kt) of Chad in 2005 and the Emissions(kt) of Denmark in 2006?
Provide a succinct answer. -2.14e+04. What is the difference between the Emissions(kt) of Chad in 2005 and the Emissions(kt) of Lebanon in 2006?
Your answer should be very brief. -1.19e+04. What is the difference between the Emissions(kt) of Chad in 2005 and the Emissions(kt) of United Kingdom in 2006?
Give a very brief answer. -1.90e+05. What is the difference between the Emissions(kt) in Denmark in 2005 and the Emissions(kt) in Lebanon in 2006?
Provide a short and direct response. 9068.49. What is the difference between the Emissions(kt) in Denmark in 2005 and the Emissions(kt) in United Kingdom in 2006?
Offer a very short reply. -1.69e+05. What is the difference between the Emissions(kt) of Lebanon in 2005 and the Emissions(kt) of United Kingdom in 2006?
Keep it short and to the point. -1.77e+05. What is the average Emissions(kt) in Chad per year?
Make the answer very short. 275.48. What is the average Emissions(kt) of Denmark per year?
Make the answer very short. 2.32e+04. What is the average Emissions(kt) of Lebanon per year?
Provide a succinct answer. 1.40e+04. What is the average Emissions(kt) in United Kingdom per year?
Make the answer very short. 1.91e+05. In the year 1999, what is the difference between the Emissions(kt) of Chad and Emissions(kt) of Denmark?
Provide a short and direct response. -2.51e+04. In the year 1999, what is the difference between the Emissions(kt) in Chad and Emissions(kt) in Lebanon?
Your answer should be very brief. -1.45e+04. In the year 1999, what is the difference between the Emissions(kt) of Chad and Emissions(kt) of United Kingdom?
Provide a succinct answer. -1.97e+05. In the year 1999, what is the difference between the Emissions(kt) of Denmark and Emissions(kt) of Lebanon?
Provide a succinct answer. 1.06e+04. In the year 1999, what is the difference between the Emissions(kt) in Denmark and Emissions(kt) in United Kingdom?
Keep it short and to the point. -1.71e+05. In the year 1999, what is the difference between the Emissions(kt) of Lebanon and Emissions(kt) of United Kingdom?
Make the answer very short. -1.82e+05. In the year 2000, what is the difference between the Emissions(kt) of Chad and Emissions(kt) of Denmark?
Your answer should be compact. -2.42e+04. In the year 2000, what is the difference between the Emissions(kt) of Chad and Emissions(kt) of Lebanon?
Ensure brevity in your answer.  -1.32e+04. In the year 2000, what is the difference between the Emissions(kt) of Chad and Emissions(kt) of United Kingdom?
Your answer should be compact. -1.94e+05. In the year 2000, what is the difference between the Emissions(kt) in Denmark and Emissions(kt) in Lebanon?
Ensure brevity in your answer.  1.10e+04. In the year 2000, what is the difference between the Emissions(kt) of Denmark and Emissions(kt) of United Kingdom?
Your response must be concise. -1.70e+05. In the year 2000, what is the difference between the Emissions(kt) in Lebanon and Emissions(kt) in United Kingdom?
Make the answer very short. -1.81e+05. In the year 2001, what is the difference between the Emissions(kt) in Chad and Emissions(kt) in Denmark?
Offer a very short reply. -2.46e+04. In the year 2001, what is the difference between the Emissions(kt) in Chad and Emissions(kt) in Lebanon?
Your response must be concise. -1.41e+04. In the year 2001, what is the difference between the Emissions(kt) of Chad and Emissions(kt) of United Kingdom?
Ensure brevity in your answer.  -1.90e+05. In the year 2001, what is the difference between the Emissions(kt) in Denmark and Emissions(kt) in Lebanon?
Keep it short and to the point. 1.05e+04. In the year 2001, what is the difference between the Emissions(kt) of Denmark and Emissions(kt) of United Kingdom?
Offer a terse response. -1.66e+05. In the year 2001, what is the difference between the Emissions(kt) in Lebanon and Emissions(kt) in United Kingdom?
Your response must be concise. -1.76e+05. In the year 2002, what is the difference between the Emissions(kt) in Chad and Emissions(kt) in Denmark?
Keep it short and to the point. -2.37e+04. In the year 2002, what is the difference between the Emissions(kt) in Chad and Emissions(kt) in Lebanon?
Keep it short and to the point. -1.39e+04. In the year 2002, what is the difference between the Emissions(kt) of Chad and Emissions(kt) of United Kingdom?
Offer a very short reply. -1.86e+05. In the year 2002, what is the difference between the Emissions(kt) in Denmark and Emissions(kt) in Lebanon?
Your answer should be very brief. 9750.55. In the year 2002, what is the difference between the Emissions(kt) in Denmark and Emissions(kt) in United Kingdom?
Offer a terse response. -1.62e+05. In the year 2002, what is the difference between the Emissions(kt) of Lebanon and Emissions(kt) of United Kingdom?
Your answer should be compact. -1.72e+05. In the year 2003, what is the difference between the Emissions(kt) of Chad and Emissions(kt) of Denmark?
Your answer should be compact. -2.20e+04. In the year 2003, what is the difference between the Emissions(kt) of Chad and Emissions(kt) of Lebanon?
Provide a short and direct response. -1.54e+04. In the year 2003, what is the difference between the Emissions(kt) of Chad and Emissions(kt) of United Kingdom?
Offer a terse response. -1.87e+05. In the year 2003, what is the difference between the Emissions(kt) of Denmark and Emissions(kt) of Lebanon?
Offer a very short reply. 6589.6. In the year 2003, what is the difference between the Emissions(kt) in Denmark and Emissions(kt) in United Kingdom?
Your answer should be very brief. -1.65e+05. In the year 2003, what is the difference between the Emissions(kt) of Lebanon and Emissions(kt) of United Kingdom?
Provide a short and direct response. -1.72e+05. In the year 2004, what is the difference between the Emissions(kt) of Chad and Emissions(kt) of Denmark?
Your response must be concise. -2.15e+04. In the year 2004, what is the difference between the Emissions(kt) in Chad and Emissions(kt) in Lebanon?
Your answer should be compact. -1.37e+04. In the year 2004, what is the difference between the Emissions(kt) of Chad and Emissions(kt) of United Kingdom?
Your answer should be very brief. -1.87e+05. In the year 2004, what is the difference between the Emissions(kt) of Denmark and Emissions(kt) of Lebanon?
Keep it short and to the point. 7807.04. In the year 2004, what is the difference between the Emissions(kt) in Denmark and Emissions(kt) in United Kingdom?
Your answer should be compact. -1.66e+05. In the year 2004, what is the difference between the Emissions(kt) in Lebanon and Emissions(kt) in United Kingdom?
Provide a succinct answer. -1.74e+05. In the year 2005, what is the difference between the Emissions(kt) of Chad and Emissions(kt) of Denmark?
Your answer should be very brief. -2.10e+04. In the year 2005, what is the difference between the Emissions(kt) of Chad and Emissions(kt) of Lebanon?
Ensure brevity in your answer.  -1.30e+04. In the year 2005, what is the difference between the Emissions(kt) in Chad and Emissions(kt) in United Kingdom?
Your answer should be compact. -1.93e+05. In the year 2005, what is the difference between the Emissions(kt) in Denmark and Emissions(kt) in Lebanon?
Offer a terse response. 7946.39. In the year 2005, what is the difference between the Emissions(kt) of Denmark and Emissions(kt) of United Kingdom?
Make the answer very short. -1.72e+05. In the year 2005, what is the difference between the Emissions(kt) of Lebanon and Emissions(kt) of United Kingdom?
Provide a short and direct response. -1.80e+05. In the year 2006, what is the difference between the Emissions(kt) of Chad and Emissions(kt) of Denmark?
Give a very brief answer. -2.14e+04. In the year 2006, what is the difference between the Emissions(kt) in Chad and Emissions(kt) in Lebanon?
Keep it short and to the point. -1.19e+04. In the year 2006, what is the difference between the Emissions(kt) of Chad and Emissions(kt) of United Kingdom?
Your response must be concise. -1.90e+05. In the year 2006, what is the difference between the Emissions(kt) of Denmark and Emissions(kt) of Lebanon?
Make the answer very short. 9475.53. In the year 2006, what is the difference between the Emissions(kt) in Denmark and Emissions(kt) in United Kingdom?
Provide a short and direct response. -1.69e+05. In the year 2006, what is the difference between the Emissions(kt) of Lebanon and Emissions(kt) of United Kingdom?
Offer a terse response. -1.78e+05. What is the ratio of the Emissions(kt) of Chad in 1999 to that in 2000?
Provide a succinct answer. 0.69. What is the ratio of the Emissions(kt) of Denmark in 1999 to that in 2000?
Provide a succinct answer. 1.04. What is the ratio of the Emissions(kt) in Lebanon in 1999 to that in 2000?
Ensure brevity in your answer.  1.09. What is the ratio of the Emissions(kt) of United Kingdom in 1999 to that in 2000?
Your answer should be compact. 1.01. What is the ratio of the Emissions(kt) of Chad in 1999 to that in 2001?
Offer a very short reply. 0.7. What is the ratio of the Emissions(kt) of Denmark in 1999 to that in 2001?
Your response must be concise. 1.02. What is the ratio of the Emissions(kt) in Lebanon in 1999 to that in 2001?
Offer a terse response. 1.03. What is the ratio of the Emissions(kt) of United Kingdom in 1999 to that in 2001?
Make the answer very short. 1.03. What is the ratio of the Emissions(kt) in Chad in 1999 to that in 2002?
Provide a short and direct response. 0.72. What is the ratio of the Emissions(kt) of Denmark in 1999 to that in 2002?
Your answer should be very brief. 1.06. What is the ratio of the Emissions(kt) in Lebanon in 1999 to that in 2002?
Offer a very short reply. 1.04. What is the ratio of the Emissions(kt) of United Kingdom in 1999 to that in 2002?
Offer a very short reply. 1.06. What is the ratio of the Emissions(kt) of Chad in 1999 to that in 2003?
Your answer should be very brief. 0.32. What is the ratio of the Emissions(kt) in Denmark in 1999 to that in 2003?
Your answer should be compact. 1.13. What is the ratio of the Emissions(kt) in Lebanon in 1999 to that in 2003?
Your response must be concise. 0.93. What is the ratio of the Emissions(kt) in United Kingdom in 1999 to that in 2003?
Offer a very short reply. 1.05. What is the ratio of the Emissions(kt) of Chad in 1999 to that in 2004?
Keep it short and to the point. 0.32. What is the ratio of the Emissions(kt) in Denmark in 1999 to that in 2004?
Offer a very short reply. 1.15. What is the ratio of the Emissions(kt) in Lebanon in 1999 to that in 2004?
Make the answer very short. 1.04. What is the ratio of the Emissions(kt) in United Kingdom in 1999 to that in 2004?
Offer a terse response. 1.05. What is the ratio of the Emissions(kt) of Chad in 1999 to that in 2005?
Provide a succinct answer. 0.3. What is the ratio of the Emissions(kt) in Denmark in 1999 to that in 2005?
Make the answer very short. 1.18. What is the ratio of the Emissions(kt) of Lebanon in 1999 to that in 2005?
Give a very brief answer. 1.09. What is the ratio of the Emissions(kt) of United Kingdom in 1999 to that in 2005?
Your answer should be compact. 1.01. What is the ratio of the Emissions(kt) in Chad in 1999 to that in 2006?
Your response must be concise. 0.3. What is the ratio of the Emissions(kt) of Denmark in 1999 to that in 2006?
Your answer should be very brief. 1.16. What is the ratio of the Emissions(kt) in Lebanon in 1999 to that in 2006?
Your answer should be very brief. 1.19. What is the ratio of the Emissions(kt) in United Kingdom in 1999 to that in 2006?
Your answer should be compact. 1.03. What is the ratio of the Emissions(kt) of Chad in 2000 to that in 2001?
Offer a very short reply. 1.02. What is the ratio of the Emissions(kt) of Denmark in 2000 to that in 2001?
Your answer should be compact. 0.99. What is the ratio of the Emissions(kt) of Lebanon in 2000 to that in 2001?
Keep it short and to the point. 0.94. What is the ratio of the Emissions(kt) of United Kingdom in 2000 to that in 2001?
Offer a very short reply. 1.02. What is the ratio of the Emissions(kt) of Chad in 2000 to that in 2002?
Your answer should be compact. 1.04. What is the ratio of the Emissions(kt) of Denmark in 2000 to that in 2002?
Provide a succinct answer. 1.02. What is the ratio of the Emissions(kt) of Lebanon in 2000 to that in 2002?
Your answer should be very brief. 0.95. What is the ratio of the Emissions(kt) of United Kingdom in 2000 to that in 2002?
Offer a very short reply. 1.04. What is the ratio of the Emissions(kt) of Chad in 2000 to that in 2003?
Make the answer very short. 0.46. What is the ratio of the Emissions(kt) of Denmark in 2000 to that in 2003?
Provide a short and direct response. 1.09. What is the ratio of the Emissions(kt) in Lebanon in 2000 to that in 2003?
Your answer should be compact. 0.85. What is the ratio of the Emissions(kt) of United Kingdom in 2000 to that in 2003?
Provide a succinct answer. 1.03. What is the ratio of the Emissions(kt) of Chad in 2000 to that in 2004?
Offer a terse response. 0.47. What is the ratio of the Emissions(kt) of Denmark in 2000 to that in 2004?
Make the answer very short. 1.11. What is the ratio of the Emissions(kt) in Lebanon in 2000 to that in 2004?
Make the answer very short. 0.95. What is the ratio of the Emissions(kt) of United Kingdom in 2000 to that in 2004?
Offer a terse response. 1.03. What is the ratio of the Emissions(kt) of Chad in 2000 to that in 2005?
Keep it short and to the point. 0.44. What is the ratio of the Emissions(kt) in Denmark in 2000 to that in 2005?
Make the answer very short. 1.14. What is the ratio of the Emissions(kt) of United Kingdom in 2000 to that in 2005?
Keep it short and to the point. 1. What is the ratio of the Emissions(kt) of Chad in 2000 to that in 2006?
Provide a succinct answer. 0.43. What is the ratio of the Emissions(kt) in Denmark in 2000 to that in 2006?
Make the answer very short. 1.12. What is the ratio of the Emissions(kt) of Lebanon in 2000 to that in 2006?
Offer a terse response. 1.09. What is the ratio of the Emissions(kt) in United Kingdom in 2000 to that in 2006?
Provide a short and direct response. 1.02. What is the ratio of the Emissions(kt) in Chad in 2001 to that in 2002?
Ensure brevity in your answer.  1.02. What is the ratio of the Emissions(kt) in Denmark in 2001 to that in 2002?
Give a very brief answer. 1.04. What is the ratio of the Emissions(kt) of Lebanon in 2001 to that in 2002?
Keep it short and to the point. 1.01. What is the ratio of the Emissions(kt) of United Kingdom in 2001 to that in 2002?
Keep it short and to the point. 1.02. What is the ratio of the Emissions(kt) of Chad in 2001 to that in 2003?
Offer a terse response. 0.45. What is the ratio of the Emissions(kt) of Denmark in 2001 to that in 2003?
Provide a short and direct response. 1.11. What is the ratio of the Emissions(kt) of Lebanon in 2001 to that in 2003?
Provide a succinct answer. 0.9. What is the ratio of the Emissions(kt) in United Kingdom in 2001 to that in 2003?
Ensure brevity in your answer.  1.01. What is the ratio of the Emissions(kt) in Chad in 2001 to that in 2004?
Offer a very short reply. 0.46. What is the ratio of the Emissions(kt) of Denmark in 2001 to that in 2004?
Make the answer very short. 1.13. What is the ratio of the Emissions(kt) of Lebanon in 2001 to that in 2004?
Provide a succinct answer. 1.01. What is the ratio of the Emissions(kt) of United Kingdom in 2001 to that in 2004?
Make the answer very short. 1.01. What is the ratio of the Emissions(kt) in Chad in 2001 to that in 2005?
Make the answer very short. 0.43. What is the ratio of the Emissions(kt) in Denmark in 2001 to that in 2005?
Give a very brief answer. 1.16. What is the ratio of the Emissions(kt) in Lebanon in 2001 to that in 2005?
Your response must be concise. 1.06. What is the ratio of the Emissions(kt) in United Kingdom in 2001 to that in 2005?
Provide a succinct answer. 0.98. What is the ratio of the Emissions(kt) in Chad in 2001 to that in 2006?
Offer a very short reply. 0.42. What is the ratio of the Emissions(kt) in Denmark in 2001 to that in 2006?
Offer a very short reply. 1.14. What is the ratio of the Emissions(kt) of Lebanon in 2001 to that in 2006?
Keep it short and to the point. 1.16. What is the ratio of the Emissions(kt) in Chad in 2002 to that in 2003?
Ensure brevity in your answer.  0.44. What is the ratio of the Emissions(kt) in Denmark in 2002 to that in 2003?
Make the answer very short. 1.07. What is the ratio of the Emissions(kt) in Lebanon in 2002 to that in 2003?
Provide a short and direct response. 0.89. What is the ratio of the Emissions(kt) of United Kingdom in 2002 to that in 2003?
Your response must be concise. 0.99. What is the ratio of the Emissions(kt) in Chad in 2002 to that in 2004?
Keep it short and to the point. 0.45. What is the ratio of the Emissions(kt) in Denmark in 2002 to that in 2004?
Provide a short and direct response. 1.09. What is the ratio of the Emissions(kt) in United Kingdom in 2002 to that in 2004?
Give a very brief answer. 0.99. What is the ratio of the Emissions(kt) in Chad in 2002 to that in 2005?
Give a very brief answer. 0.42. What is the ratio of the Emissions(kt) of Denmark in 2002 to that in 2005?
Your answer should be very brief. 1.12. What is the ratio of the Emissions(kt) of Lebanon in 2002 to that in 2005?
Offer a very short reply. 1.05. What is the ratio of the Emissions(kt) in United Kingdom in 2002 to that in 2005?
Provide a succinct answer. 0.96. What is the ratio of the Emissions(kt) in Chad in 2002 to that in 2006?
Your response must be concise. 0.41. What is the ratio of the Emissions(kt) of Denmark in 2002 to that in 2006?
Your answer should be compact. 1.09. What is the ratio of the Emissions(kt) in Lebanon in 2002 to that in 2006?
Provide a succinct answer. 1.15. What is the ratio of the Emissions(kt) of United Kingdom in 2002 to that in 2006?
Provide a short and direct response. 0.98. What is the ratio of the Emissions(kt) of Chad in 2003 to that in 2004?
Keep it short and to the point. 1.01. What is the ratio of the Emissions(kt) in Denmark in 2003 to that in 2004?
Give a very brief answer. 1.02. What is the ratio of the Emissions(kt) of Lebanon in 2003 to that in 2004?
Provide a short and direct response. 1.12. What is the ratio of the Emissions(kt) of Chad in 2003 to that in 2005?
Give a very brief answer. 0.95. What is the ratio of the Emissions(kt) of Denmark in 2003 to that in 2005?
Give a very brief answer. 1.05. What is the ratio of the Emissions(kt) of Lebanon in 2003 to that in 2005?
Make the answer very short. 1.17. What is the ratio of the Emissions(kt) of United Kingdom in 2003 to that in 2005?
Your answer should be compact. 0.97. What is the ratio of the Emissions(kt) of Chad in 2003 to that in 2006?
Ensure brevity in your answer.  0.94. What is the ratio of the Emissions(kt) in Denmark in 2003 to that in 2006?
Provide a short and direct response. 1.03. What is the ratio of the Emissions(kt) of Lebanon in 2003 to that in 2006?
Ensure brevity in your answer.  1.28. What is the ratio of the Emissions(kt) of United Kingdom in 2003 to that in 2006?
Offer a terse response. 0.99. What is the ratio of the Emissions(kt) in Chad in 2004 to that in 2005?
Your response must be concise. 0.94. What is the ratio of the Emissions(kt) in Denmark in 2004 to that in 2005?
Provide a succinct answer. 1.03. What is the ratio of the Emissions(kt) in Lebanon in 2004 to that in 2005?
Your response must be concise. 1.05. What is the ratio of the Emissions(kt) in United Kingdom in 2004 to that in 2005?
Ensure brevity in your answer.  0.97. What is the ratio of the Emissions(kt) in Chad in 2004 to that in 2006?
Provide a short and direct response. 0.93. What is the ratio of the Emissions(kt) of Denmark in 2004 to that in 2006?
Make the answer very short. 1.01. What is the ratio of the Emissions(kt) of Lebanon in 2004 to that in 2006?
Your answer should be compact. 1.15. What is the ratio of the Emissions(kt) in United Kingdom in 2004 to that in 2006?
Offer a very short reply. 0.99. What is the ratio of the Emissions(kt) of Denmark in 2005 to that in 2006?
Offer a very short reply. 0.98. What is the ratio of the Emissions(kt) of Lebanon in 2005 to that in 2006?
Your response must be concise. 1.09. What is the difference between the highest and the second highest Emissions(kt) in Chad?
Provide a short and direct response. 7.33. What is the difference between the highest and the second highest Emissions(kt) of Denmark?
Give a very brief answer. 531.72. What is the difference between the highest and the second highest Emissions(kt) of Lebanon?
Provide a short and direct response. 1133.1. What is the difference between the highest and the second highest Emissions(kt) of United Kingdom?
Give a very brief answer. 2739.25. What is the difference between the highest and the lowest Emissions(kt) in Chad?
Keep it short and to the point. 286.03. What is the difference between the highest and the lowest Emissions(kt) in Denmark?
Make the answer very short. 3890.69. What is the difference between the highest and the lowest Emissions(kt) of Lebanon?
Your answer should be very brief. 3446.98. What is the difference between the highest and the lowest Emissions(kt) of United Kingdom?
Provide a short and direct response. 1.07e+04. 